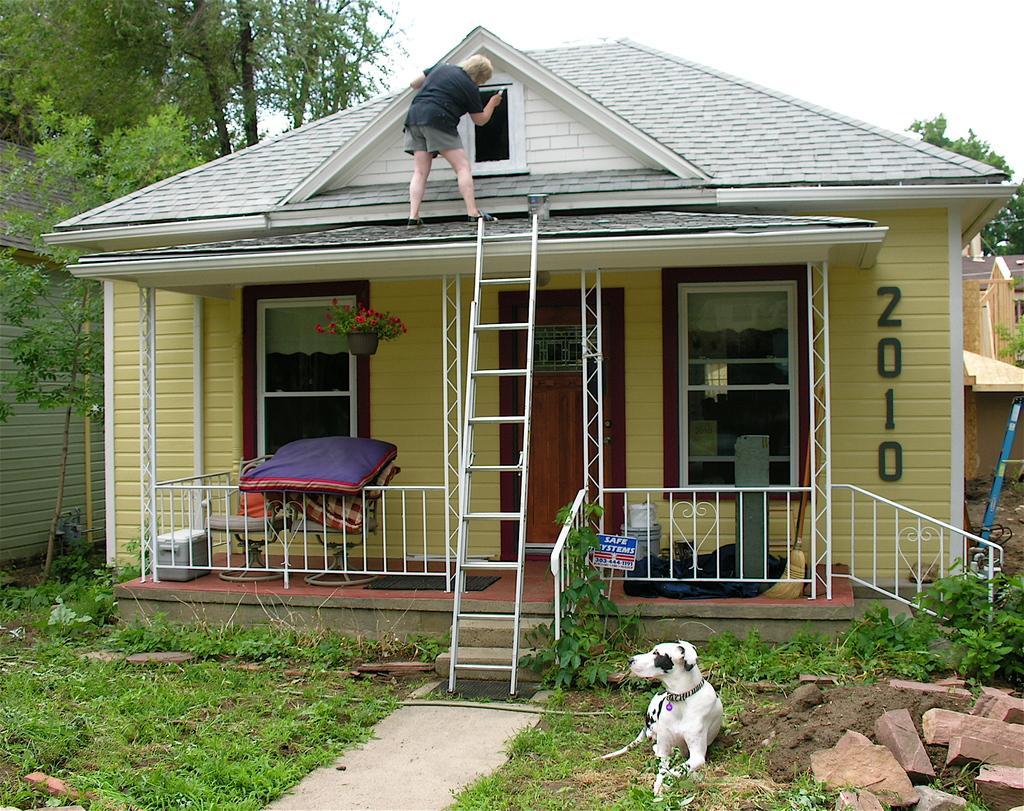Could you give a brief overview of what you see in this image? On the right side, there are bricks, stones, mud and a white color dog on the grass on the ground. On the left side, there is a path and there's grass on the ground. In the background, there is a ladder on a building, on which there is a person, this building is having a roof, windows, a door and two fences, there are trees, buildings and there are clouds in the sky. 